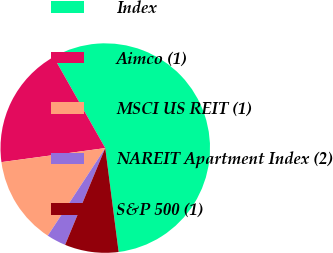<chart> <loc_0><loc_0><loc_500><loc_500><pie_chart><fcel>Index<fcel>Aimco (1)<fcel>MSCI US REIT (1)<fcel>NAREIT Apartment Index (2)<fcel>S&P 500 (1)<nl><fcel>56.16%<fcel>18.94%<fcel>13.62%<fcel>2.98%<fcel>8.3%<nl></chart> 